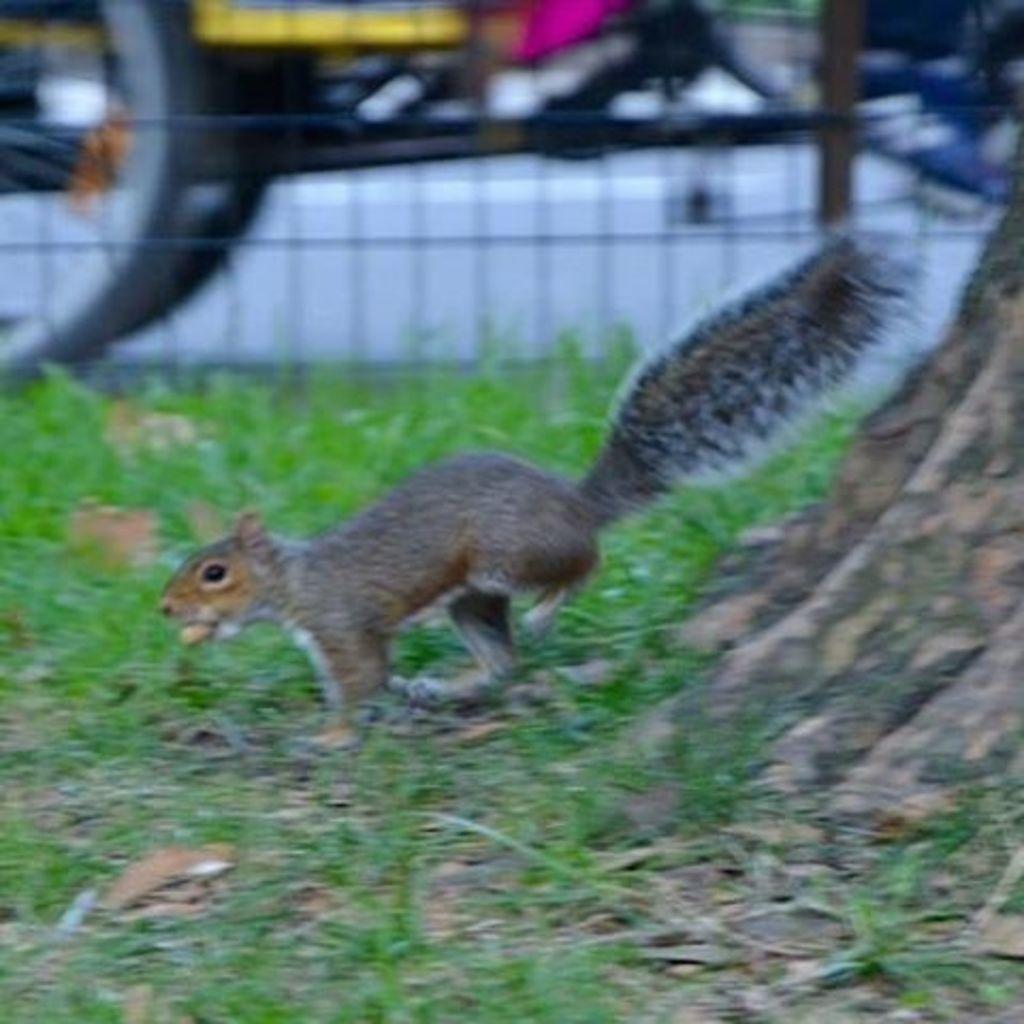What animal can be seen in the picture? There is a squirrel in the picture. What is the squirrel doing in the image? The squirrel is moving on the grass. Can you describe the surface behind the grass? There is a mesh behind the grass. How would you describe the background of the image? The background of the image is blurry. How many cats and pigs are interacting with the squirrel in the image? There are no cats or pigs present in the image; it only features a squirrel moving on the grass. Did the squirrel cause the earthquake in the image? There is no earthquake depicted in the image, and the squirrel's actions do not cause any earthquakes. 